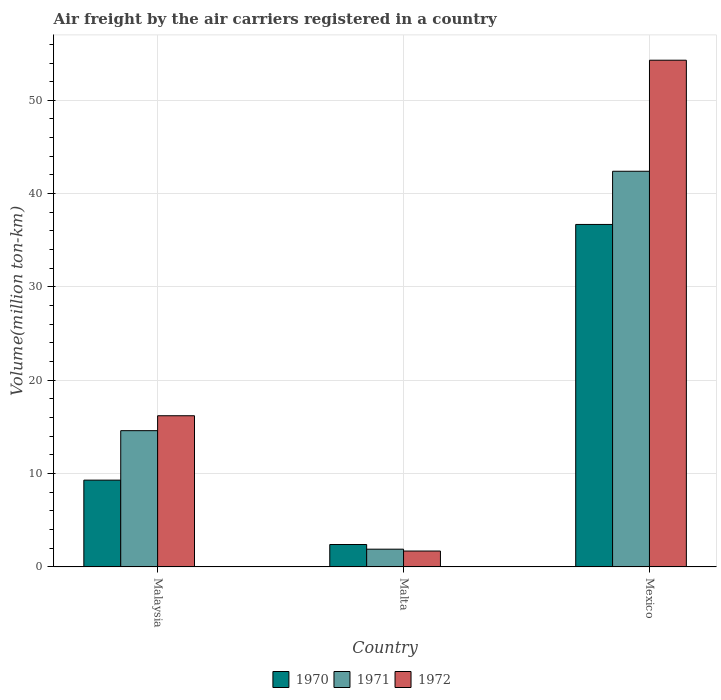How many bars are there on the 2nd tick from the left?
Your answer should be compact. 3. What is the label of the 1st group of bars from the left?
Your answer should be compact. Malaysia. What is the volume of the air carriers in 1970 in Malta?
Make the answer very short. 2.4. Across all countries, what is the maximum volume of the air carriers in 1970?
Your answer should be compact. 36.7. Across all countries, what is the minimum volume of the air carriers in 1972?
Give a very brief answer. 1.7. In which country was the volume of the air carriers in 1971 minimum?
Offer a very short reply. Malta. What is the total volume of the air carriers in 1971 in the graph?
Give a very brief answer. 58.9. What is the difference between the volume of the air carriers in 1972 in Malaysia and that in Malta?
Make the answer very short. 14.5. What is the difference between the volume of the air carriers in 1971 in Malaysia and the volume of the air carriers in 1972 in Malta?
Your response must be concise. 12.9. What is the average volume of the air carriers in 1972 per country?
Your response must be concise. 24.07. What is the difference between the volume of the air carriers of/in 1971 and volume of the air carriers of/in 1972 in Malaysia?
Your answer should be very brief. -1.6. In how many countries, is the volume of the air carriers in 1970 greater than 26 million ton-km?
Provide a succinct answer. 1. What is the ratio of the volume of the air carriers in 1972 in Malta to that in Mexico?
Keep it short and to the point. 0.03. Is the volume of the air carriers in 1970 in Malta less than that in Mexico?
Make the answer very short. Yes. What is the difference between the highest and the second highest volume of the air carriers in 1972?
Your answer should be very brief. 14.5. What is the difference between the highest and the lowest volume of the air carriers in 1970?
Provide a succinct answer. 34.3. In how many countries, is the volume of the air carriers in 1971 greater than the average volume of the air carriers in 1971 taken over all countries?
Keep it short and to the point. 1. Is the sum of the volume of the air carriers in 1971 in Malta and Mexico greater than the maximum volume of the air carriers in 1970 across all countries?
Your answer should be compact. Yes. What does the 3rd bar from the right in Mexico represents?
Your answer should be very brief. 1970. Is it the case that in every country, the sum of the volume of the air carriers in 1970 and volume of the air carriers in 1972 is greater than the volume of the air carriers in 1971?
Your response must be concise. Yes. How many countries are there in the graph?
Your response must be concise. 3. Does the graph contain grids?
Your response must be concise. Yes. How many legend labels are there?
Offer a very short reply. 3. How are the legend labels stacked?
Give a very brief answer. Horizontal. What is the title of the graph?
Provide a succinct answer. Air freight by the air carriers registered in a country. What is the label or title of the X-axis?
Provide a succinct answer. Country. What is the label or title of the Y-axis?
Ensure brevity in your answer.  Volume(million ton-km). What is the Volume(million ton-km) of 1970 in Malaysia?
Your answer should be very brief. 9.3. What is the Volume(million ton-km) in 1971 in Malaysia?
Your answer should be compact. 14.6. What is the Volume(million ton-km) in 1972 in Malaysia?
Keep it short and to the point. 16.2. What is the Volume(million ton-km) in 1970 in Malta?
Make the answer very short. 2.4. What is the Volume(million ton-km) of 1971 in Malta?
Give a very brief answer. 1.9. What is the Volume(million ton-km) of 1972 in Malta?
Your response must be concise. 1.7. What is the Volume(million ton-km) in 1970 in Mexico?
Your response must be concise. 36.7. What is the Volume(million ton-km) in 1971 in Mexico?
Keep it short and to the point. 42.4. What is the Volume(million ton-km) in 1972 in Mexico?
Provide a succinct answer. 54.3. Across all countries, what is the maximum Volume(million ton-km) in 1970?
Offer a very short reply. 36.7. Across all countries, what is the maximum Volume(million ton-km) in 1971?
Your response must be concise. 42.4. Across all countries, what is the maximum Volume(million ton-km) in 1972?
Keep it short and to the point. 54.3. Across all countries, what is the minimum Volume(million ton-km) of 1970?
Keep it short and to the point. 2.4. Across all countries, what is the minimum Volume(million ton-km) of 1971?
Your response must be concise. 1.9. Across all countries, what is the minimum Volume(million ton-km) in 1972?
Your response must be concise. 1.7. What is the total Volume(million ton-km) in 1970 in the graph?
Ensure brevity in your answer.  48.4. What is the total Volume(million ton-km) of 1971 in the graph?
Provide a short and direct response. 58.9. What is the total Volume(million ton-km) of 1972 in the graph?
Offer a very short reply. 72.2. What is the difference between the Volume(million ton-km) in 1970 in Malaysia and that in Malta?
Offer a very short reply. 6.9. What is the difference between the Volume(million ton-km) of 1972 in Malaysia and that in Malta?
Give a very brief answer. 14.5. What is the difference between the Volume(million ton-km) of 1970 in Malaysia and that in Mexico?
Give a very brief answer. -27.4. What is the difference between the Volume(million ton-km) of 1971 in Malaysia and that in Mexico?
Give a very brief answer. -27.8. What is the difference between the Volume(million ton-km) of 1972 in Malaysia and that in Mexico?
Your answer should be very brief. -38.1. What is the difference between the Volume(million ton-km) in 1970 in Malta and that in Mexico?
Provide a succinct answer. -34.3. What is the difference between the Volume(million ton-km) in 1971 in Malta and that in Mexico?
Give a very brief answer. -40.5. What is the difference between the Volume(million ton-km) of 1972 in Malta and that in Mexico?
Offer a very short reply. -52.6. What is the difference between the Volume(million ton-km) in 1970 in Malaysia and the Volume(million ton-km) in 1971 in Malta?
Offer a terse response. 7.4. What is the difference between the Volume(million ton-km) in 1970 in Malaysia and the Volume(million ton-km) in 1971 in Mexico?
Provide a short and direct response. -33.1. What is the difference between the Volume(million ton-km) in 1970 in Malaysia and the Volume(million ton-km) in 1972 in Mexico?
Keep it short and to the point. -45. What is the difference between the Volume(million ton-km) in 1971 in Malaysia and the Volume(million ton-km) in 1972 in Mexico?
Your answer should be very brief. -39.7. What is the difference between the Volume(million ton-km) in 1970 in Malta and the Volume(million ton-km) in 1972 in Mexico?
Your answer should be compact. -51.9. What is the difference between the Volume(million ton-km) in 1971 in Malta and the Volume(million ton-km) in 1972 in Mexico?
Your answer should be very brief. -52.4. What is the average Volume(million ton-km) of 1970 per country?
Keep it short and to the point. 16.13. What is the average Volume(million ton-km) in 1971 per country?
Your answer should be very brief. 19.63. What is the average Volume(million ton-km) of 1972 per country?
Your response must be concise. 24.07. What is the difference between the Volume(million ton-km) of 1970 and Volume(million ton-km) of 1971 in Malaysia?
Provide a succinct answer. -5.3. What is the difference between the Volume(million ton-km) in 1970 and Volume(million ton-km) in 1972 in Malaysia?
Provide a short and direct response. -6.9. What is the difference between the Volume(million ton-km) in 1970 and Volume(million ton-km) in 1972 in Malta?
Keep it short and to the point. 0.7. What is the difference between the Volume(million ton-km) in 1971 and Volume(million ton-km) in 1972 in Malta?
Make the answer very short. 0.2. What is the difference between the Volume(million ton-km) in 1970 and Volume(million ton-km) in 1972 in Mexico?
Your answer should be very brief. -17.6. What is the difference between the Volume(million ton-km) in 1971 and Volume(million ton-km) in 1972 in Mexico?
Provide a succinct answer. -11.9. What is the ratio of the Volume(million ton-km) in 1970 in Malaysia to that in Malta?
Your response must be concise. 3.88. What is the ratio of the Volume(million ton-km) in 1971 in Malaysia to that in Malta?
Give a very brief answer. 7.68. What is the ratio of the Volume(million ton-km) of 1972 in Malaysia to that in Malta?
Keep it short and to the point. 9.53. What is the ratio of the Volume(million ton-km) in 1970 in Malaysia to that in Mexico?
Make the answer very short. 0.25. What is the ratio of the Volume(million ton-km) in 1971 in Malaysia to that in Mexico?
Provide a succinct answer. 0.34. What is the ratio of the Volume(million ton-km) in 1972 in Malaysia to that in Mexico?
Ensure brevity in your answer.  0.3. What is the ratio of the Volume(million ton-km) in 1970 in Malta to that in Mexico?
Offer a very short reply. 0.07. What is the ratio of the Volume(million ton-km) of 1971 in Malta to that in Mexico?
Provide a succinct answer. 0.04. What is the ratio of the Volume(million ton-km) in 1972 in Malta to that in Mexico?
Keep it short and to the point. 0.03. What is the difference between the highest and the second highest Volume(million ton-km) in 1970?
Your response must be concise. 27.4. What is the difference between the highest and the second highest Volume(million ton-km) in 1971?
Provide a succinct answer. 27.8. What is the difference between the highest and the second highest Volume(million ton-km) in 1972?
Your answer should be compact. 38.1. What is the difference between the highest and the lowest Volume(million ton-km) of 1970?
Your answer should be compact. 34.3. What is the difference between the highest and the lowest Volume(million ton-km) of 1971?
Keep it short and to the point. 40.5. What is the difference between the highest and the lowest Volume(million ton-km) in 1972?
Give a very brief answer. 52.6. 